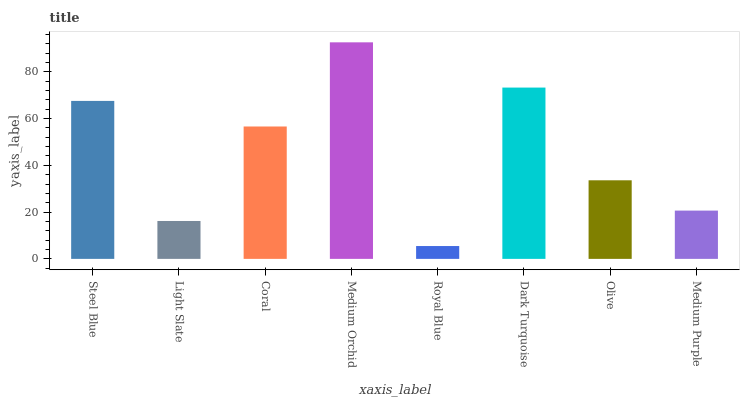Is Royal Blue the minimum?
Answer yes or no. Yes. Is Medium Orchid the maximum?
Answer yes or no. Yes. Is Light Slate the minimum?
Answer yes or no. No. Is Light Slate the maximum?
Answer yes or no. No. Is Steel Blue greater than Light Slate?
Answer yes or no. Yes. Is Light Slate less than Steel Blue?
Answer yes or no. Yes. Is Light Slate greater than Steel Blue?
Answer yes or no. No. Is Steel Blue less than Light Slate?
Answer yes or no. No. Is Coral the high median?
Answer yes or no. Yes. Is Olive the low median?
Answer yes or no. Yes. Is Light Slate the high median?
Answer yes or no. No. Is Dark Turquoise the low median?
Answer yes or no. No. 